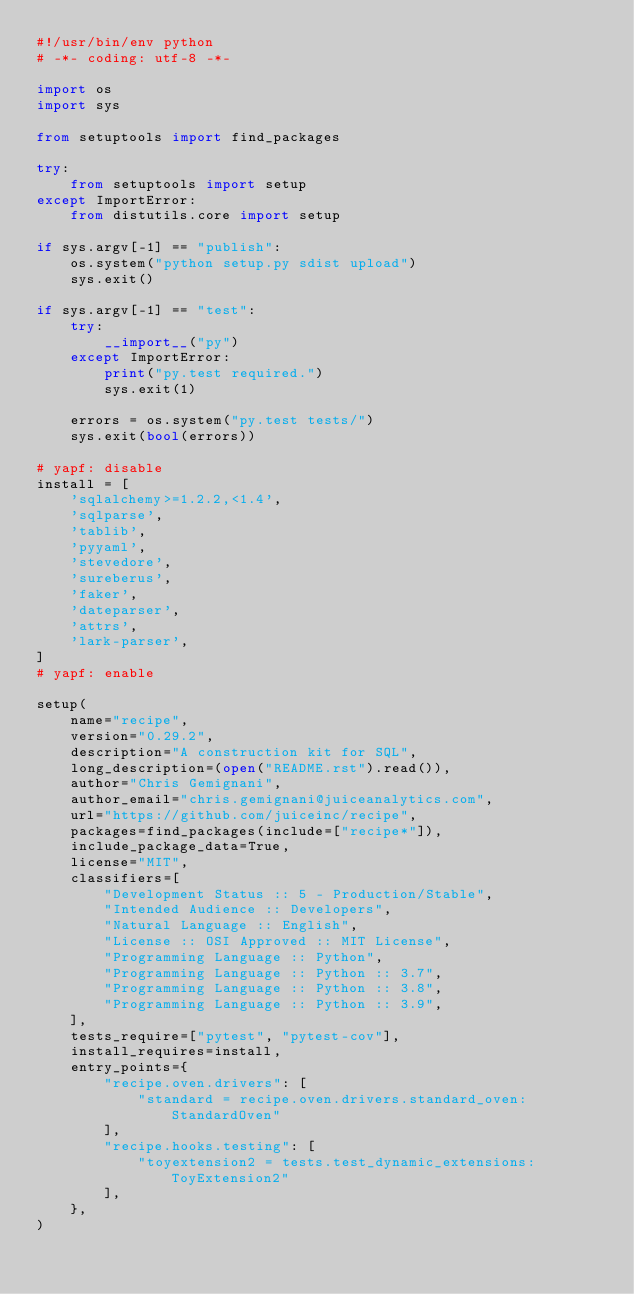<code> <loc_0><loc_0><loc_500><loc_500><_Python_>#!/usr/bin/env python
# -*- coding: utf-8 -*-

import os
import sys

from setuptools import find_packages

try:
    from setuptools import setup
except ImportError:
    from distutils.core import setup

if sys.argv[-1] == "publish":
    os.system("python setup.py sdist upload")
    sys.exit()

if sys.argv[-1] == "test":
    try:
        __import__("py")
    except ImportError:
        print("py.test required.")
        sys.exit(1)

    errors = os.system("py.test tests/")
    sys.exit(bool(errors))

# yapf: disable
install = [
    'sqlalchemy>=1.2.2,<1.4',
    'sqlparse',
    'tablib',
    'pyyaml',
    'stevedore',
    'sureberus',
    'faker',
    'dateparser',
    'attrs',
    'lark-parser',
]
# yapf: enable

setup(
    name="recipe",
    version="0.29.2",
    description="A construction kit for SQL",
    long_description=(open("README.rst").read()),
    author="Chris Gemignani",
    author_email="chris.gemignani@juiceanalytics.com",
    url="https://github.com/juiceinc/recipe",
    packages=find_packages(include=["recipe*"]),
    include_package_data=True,
    license="MIT",
    classifiers=[
        "Development Status :: 5 - Production/Stable",
        "Intended Audience :: Developers",
        "Natural Language :: English",
        "License :: OSI Approved :: MIT License",
        "Programming Language :: Python",
        "Programming Language :: Python :: 3.7",
        "Programming Language :: Python :: 3.8",
        "Programming Language :: Python :: 3.9",
    ],
    tests_require=["pytest", "pytest-cov"],
    install_requires=install,
    entry_points={
        "recipe.oven.drivers": [
            "standard = recipe.oven.drivers.standard_oven:StandardOven"
        ],
        "recipe.hooks.testing": [
            "toyextension2 = tests.test_dynamic_extensions:ToyExtension2"
        ],
    },
)
</code> 